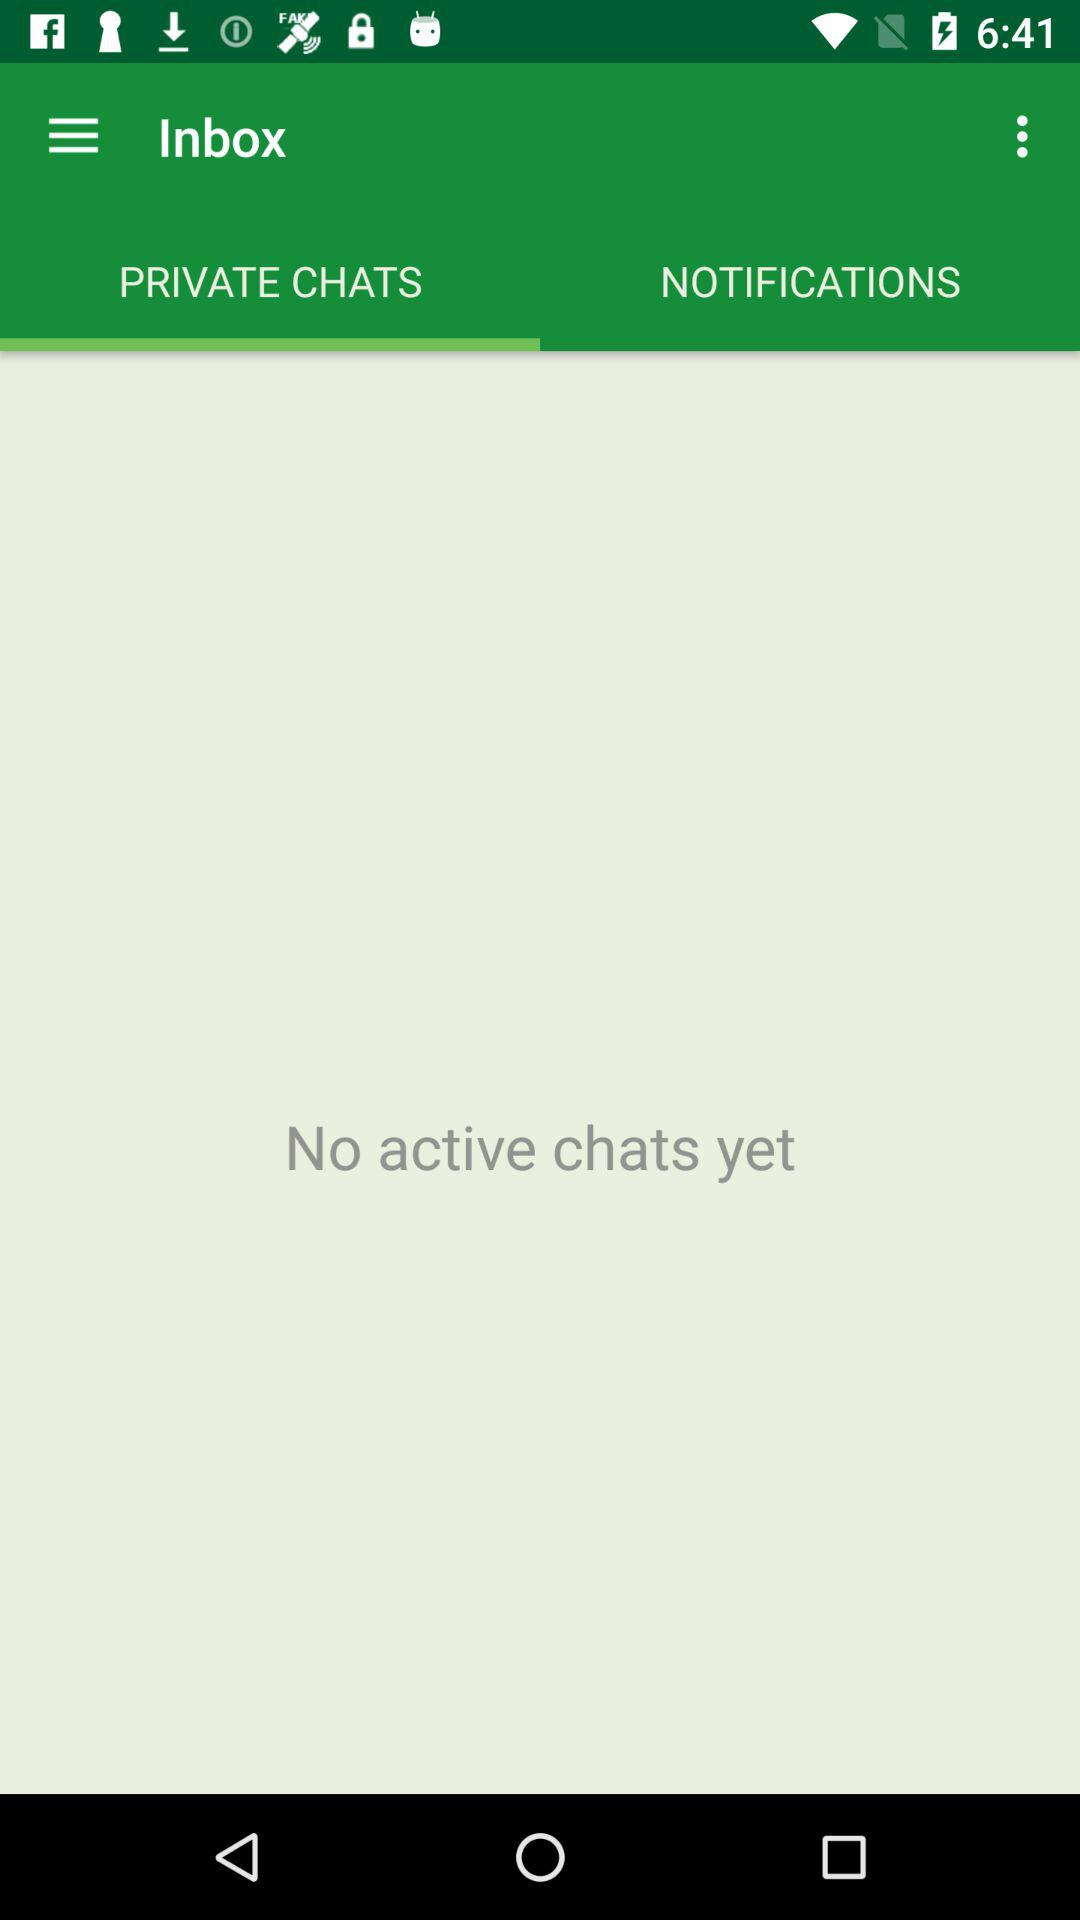Is there any active chat? There is no active chat. 